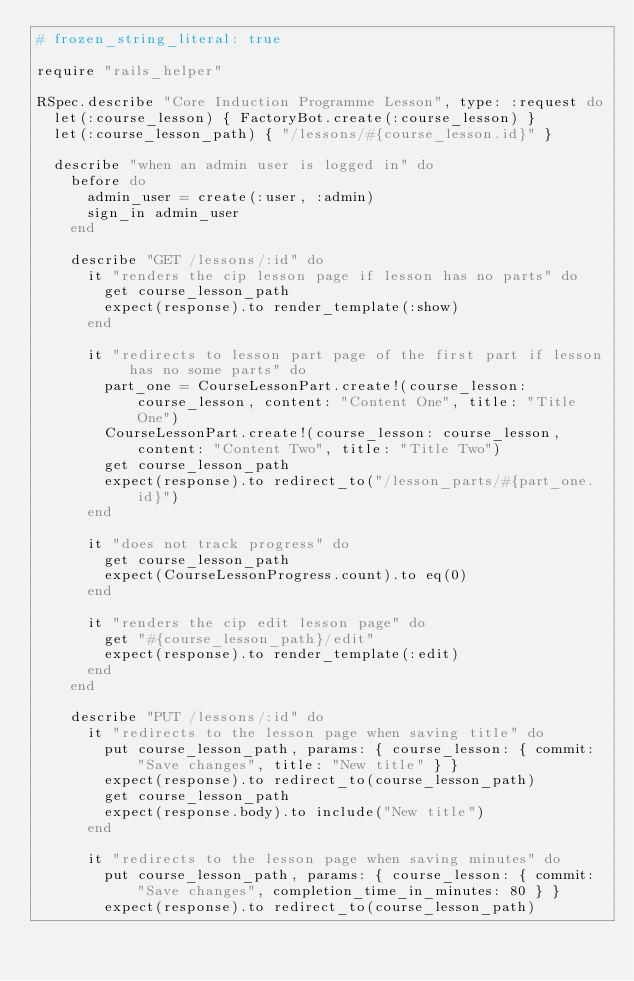<code> <loc_0><loc_0><loc_500><loc_500><_Ruby_># frozen_string_literal: true

require "rails_helper"

RSpec.describe "Core Induction Programme Lesson", type: :request do
  let(:course_lesson) { FactoryBot.create(:course_lesson) }
  let(:course_lesson_path) { "/lessons/#{course_lesson.id}" }

  describe "when an admin user is logged in" do
    before do
      admin_user = create(:user, :admin)
      sign_in admin_user
    end

    describe "GET /lessons/:id" do
      it "renders the cip lesson page if lesson has no parts" do
        get course_lesson_path
        expect(response).to render_template(:show)
      end

      it "redirects to lesson part page of the first part if lesson has no some parts" do
        part_one = CourseLessonPart.create!(course_lesson: course_lesson, content: "Content One", title: "Title One")
        CourseLessonPart.create!(course_lesson: course_lesson, content: "Content Two", title: "Title Two")
        get course_lesson_path
        expect(response).to redirect_to("/lesson_parts/#{part_one.id}")
      end

      it "does not track progress" do
        get course_lesson_path
        expect(CourseLessonProgress.count).to eq(0)
      end

      it "renders the cip edit lesson page" do
        get "#{course_lesson_path}/edit"
        expect(response).to render_template(:edit)
      end
    end

    describe "PUT /lessons/:id" do
      it "redirects to the lesson page when saving title" do
        put course_lesson_path, params: { course_lesson: { commit: "Save changes", title: "New title" } }
        expect(response).to redirect_to(course_lesson_path)
        get course_lesson_path
        expect(response.body).to include("New title")
      end

      it "redirects to the lesson page when saving minutes" do
        put course_lesson_path, params: { course_lesson: { commit: "Save changes", completion_time_in_minutes: 80 } }
        expect(response).to redirect_to(course_lesson_path)</code> 